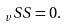Convert formula to latex. <formula><loc_0><loc_0><loc_500><loc_500>_ { v } { S } { S } = 0 .</formula> 